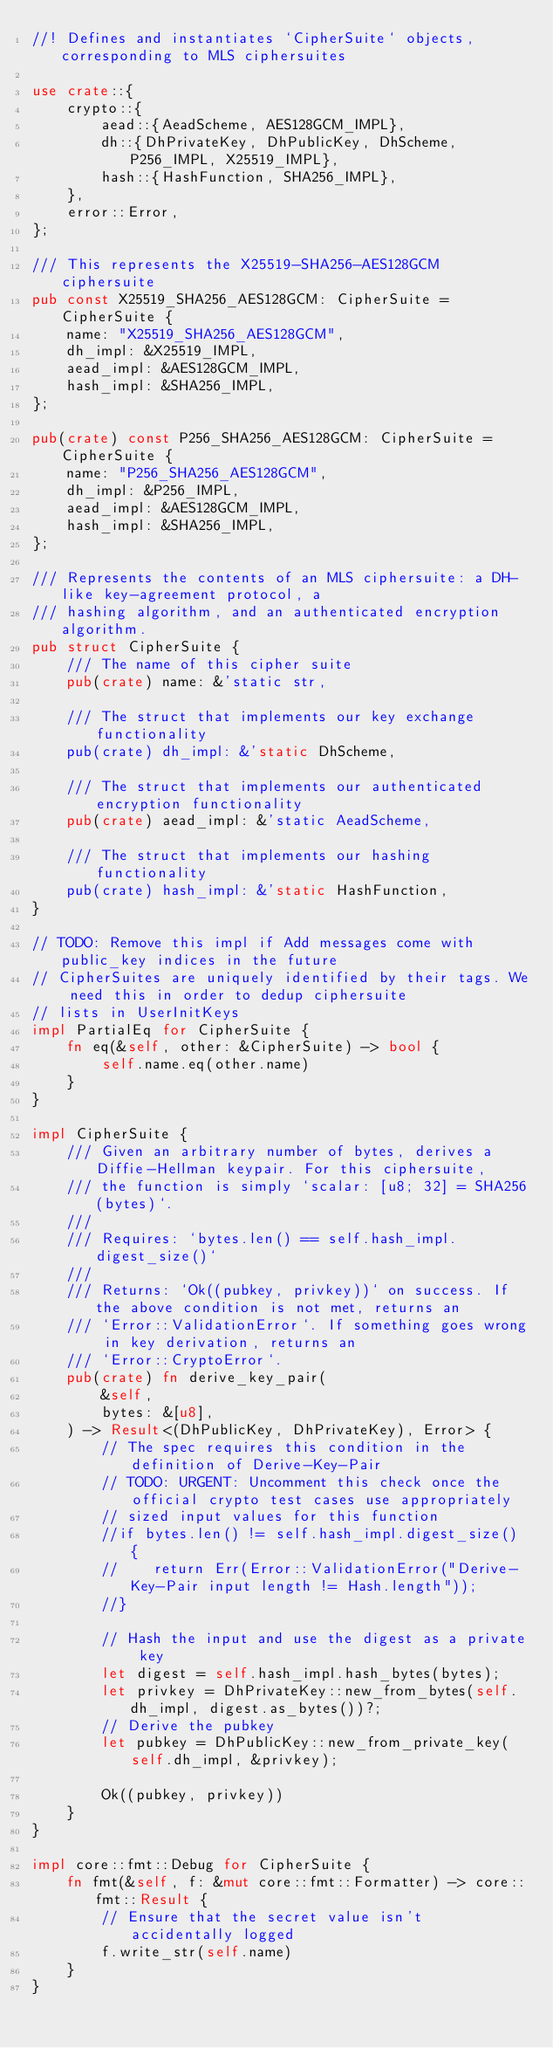<code> <loc_0><loc_0><loc_500><loc_500><_Rust_>//! Defines and instantiates `CipherSuite` objects, corresponding to MLS ciphersuites

use crate::{
    crypto::{
        aead::{AeadScheme, AES128GCM_IMPL},
        dh::{DhPrivateKey, DhPublicKey, DhScheme, P256_IMPL, X25519_IMPL},
        hash::{HashFunction, SHA256_IMPL},
    },
    error::Error,
};

/// This represents the X25519-SHA256-AES128GCM ciphersuite
pub const X25519_SHA256_AES128GCM: CipherSuite = CipherSuite {
    name: "X25519_SHA256_AES128GCM",
    dh_impl: &X25519_IMPL,
    aead_impl: &AES128GCM_IMPL,
    hash_impl: &SHA256_IMPL,
};

pub(crate) const P256_SHA256_AES128GCM: CipherSuite = CipherSuite {
    name: "P256_SHA256_AES128GCM",
    dh_impl: &P256_IMPL,
    aead_impl: &AES128GCM_IMPL,
    hash_impl: &SHA256_IMPL,
};

/// Represents the contents of an MLS ciphersuite: a DH-like key-agreement protocol, a
/// hashing algorithm, and an authenticated encryption algorithm.
pub struct CipherSuite {
    /// The name of this cipher suite
    pub(crate) name: &'static str,

    /// The struct that implements our key exchange functionality
    pub(crate) dh_impl: &'static DhScheme,

    /// The struct that implements our authenticated encryption functionality
    pub(crate) aead_impl: &'static AeadScheme,

    /// The struct that implements our hashing functionality
    pub(crate) hash_impl: &'static HashFunction,
}

// TODO: Remove this impl if Add messages come with public_key indices in the future
// CipherSuites are uniquely identified by their tags. We need this in order to dedup ciphersuite
// lists in UserInitKeys
impl PartialEq for CipherSuite {
    fn eq(&self, other: &CipherSuite) -> bool {
        self.name.eq(other.name)
    }
}

impl CipherSuite {
    /// Given an arbitrary number of bytes, derives a Diffie-Hellman keypair. For this ciphersuite,
    /// the function is simply `scalar: [u8; 32] = SHA256(bytes)`.
    ///
    /// Requires: `bytes.len() == self.hash_impl.digest_size()`
    ///
    /// Returns: `Ok((pubkey, privkey))` on success. If the above condition is not met, returns an
    /// `Error::ValidationError`. If something goes wrong in key derivation, returns an
    /// `Error::CryptoError`.
    pub(crate) fn derive_key_pair(
        &self,
        bytes: &[u8],
    ) -> Result<(DhPublicKey, DhPrivateKey), Error> {
        // The spec requires this condition in the definition of Derive-Key-Pair
        // TODO: URGENT: Uncomment this check once the official crypto test cases use appropriately
        // sized input values for this function
        //if bytes.len() != self.hash_impl.digest_size() {
        //    return Err(Error::ValidationError("Derive-Key-Pair input length != Hash.length"));
        //}

        // Hash the input and use the digest as a private key
        let digest = self.hash_impl.hash_bytes(bytes);
        let privkey = DhPrivateKey::new_from_bytes(self.dh_impl, digest.as_bytes())?;
        // Derive the pubkey
        let pubkey = DhPublicKey::new_from_private_key(self.dh_impl, &privkey);

        Ok((pubkey, privkey))
    }
}

impl core::fmt::Debug for CipherSuite {
    fn fmt(&self, f: &mut core::fmt::Formatter) -> core::fmt::Result {
        // Ensure that the secret value isn't accidentally logged
        f.write_str(self.name)
    }
}
</code> 